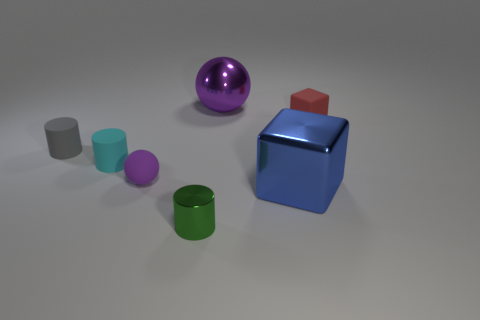What is the size of the cyan matte thing that is the same shape as the small gray matte thing?
Provide a succinct answer. Small. Are there any small cyan cylinders in front of the tiny cyan matte thing?
Keep it short and to the point. No. What is the small green thing made of?
Give a very brief answer. Metal. There is a large object behind the blue cube; is it the same color as the large metallic block?
Keep it short and to the point. No. Is there anything else that is the same shape as the tiny green object?
Offer a very short reply. Yes. What is the color of the other small matte object that is the same shape as the gray rubber thing?
Your response must be concise. Cyan. What material is the sphere in front of the gray cylinder?
Your response must be concise. Rubber. The tiny metal thing has what color?
Offer a very short reply. Green. There is a shiny object that is behind the red rubber thing; does it have the same size as the tiny cyan matte object?
Your response must be concise. No. The big thing in front of the big metal thing that is behind the large thing that is in front of the gray rubber cylinder is made of what material?
Give a very brief answer. Metal. 